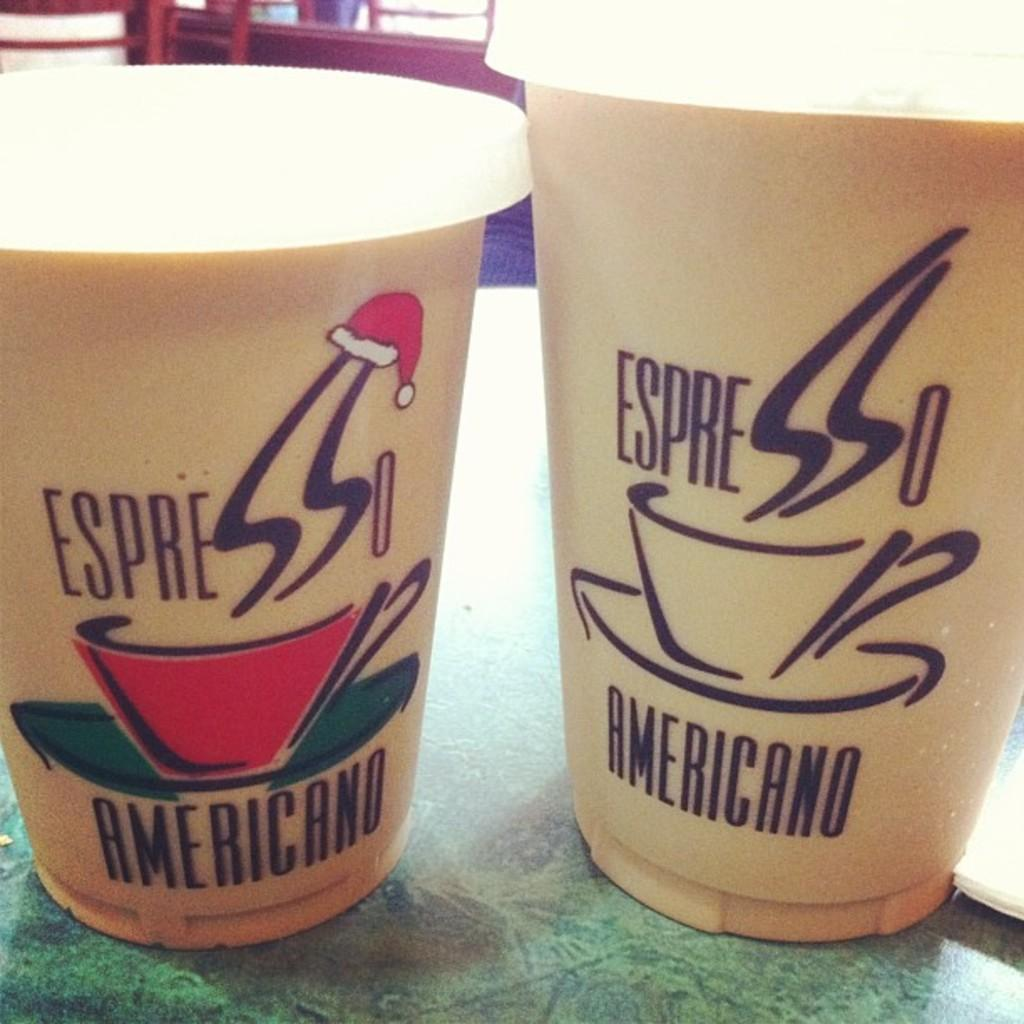What objects are on the table in the image? There are cups on the table in the image. What can be seen in the background of the image? There are chairs in the background of the image. What color are the eyes of the person using the oven in the image? There is no oven or person present in the image, so it is not possible to determine the color of their eyes. 